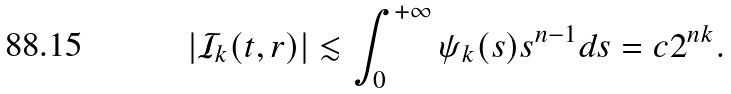Convert formula to latex. <formula><loc_0><loc_0><loc_500><loc_500>\left | \mathcal { I } _ { k } ( t , r ) \right | \lesssim \int _ { 0 } ^ { + \infty } \psi _ { k } ( s ) s ^ { n - 1 } d s = c 2 ^ { n k } .</formula> 